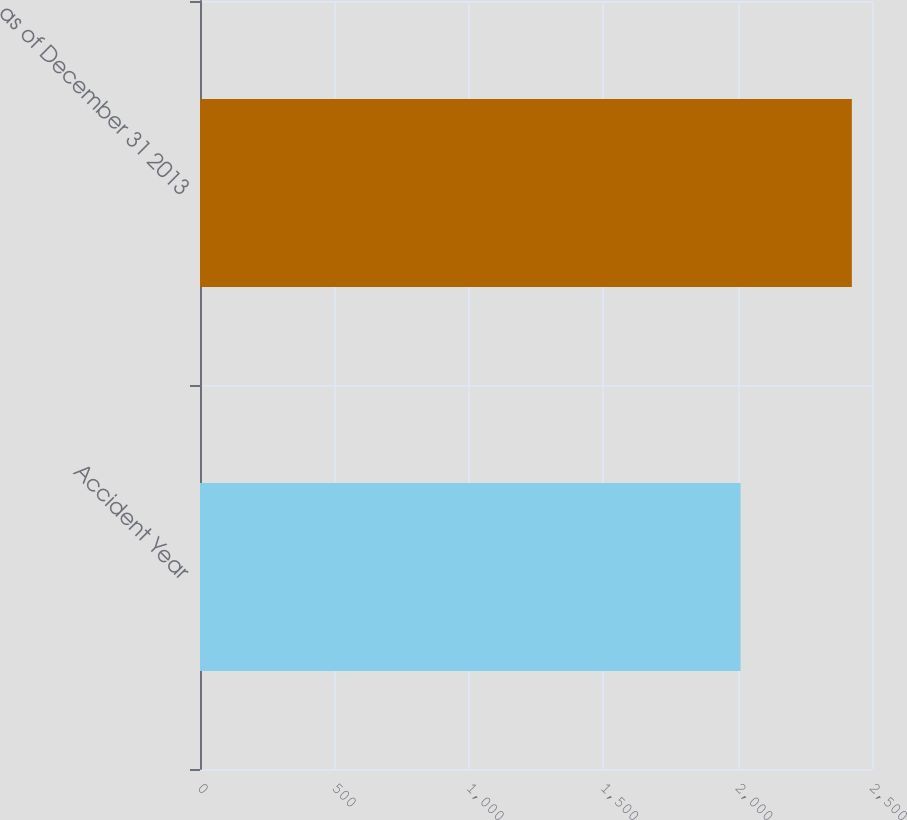<chart> <loc_0><loc_0><loc_500><loc_500><bar_chart><fcel>Accident Year<fcel>as of December 31 2013<nl><fcel>2011<fcel>2425<nl></chart> 